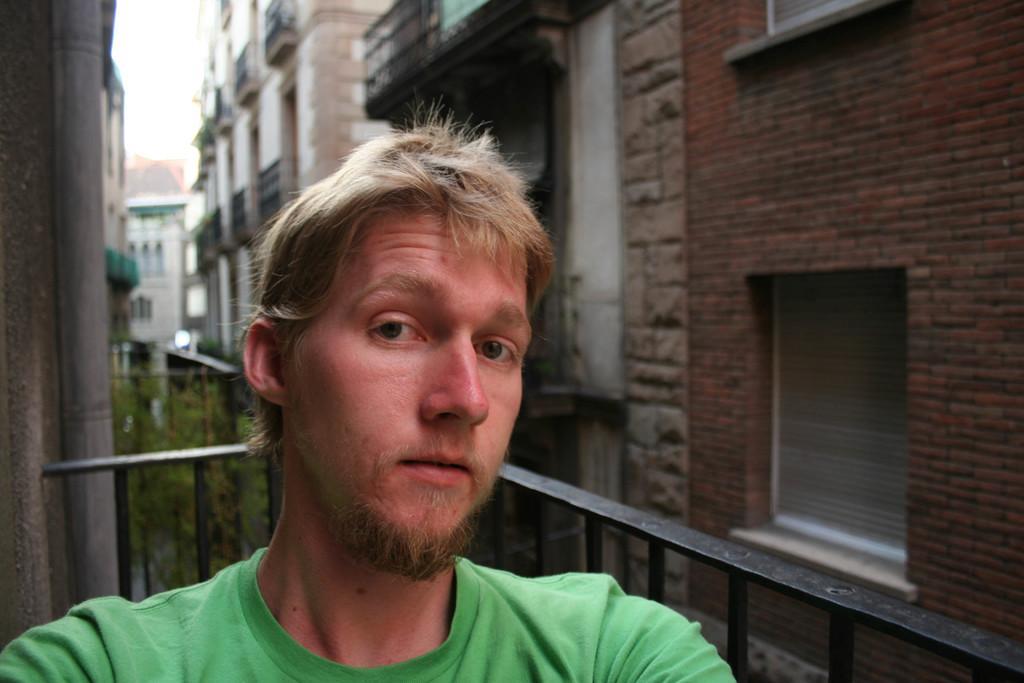Can you describe this image briefly? In the foreground of this image, there is a man wearing green T shirt. In the background, there are buildings, railing, plants and the sky. 